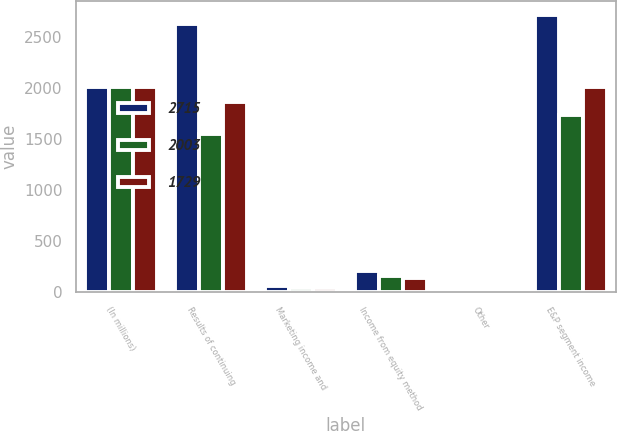<chart> <loc_0><loc_0><loc_500><loc_500><stacked_bar_chart><ecel><fcel>(In millions)<fcel>Results of continuing<fcel>Marketing income and<fcel>Income from equity method<fcel>Other<fcel>E&P segment income<nl><fcel>2715<fcel>2008<fcel>2625<fcel>58<fcel>201<fcel>6<fcel>2715<nl><fcel>2003<fcel>2007<fcel>1545<fcel>36<fcel>154<fcel>6<fcel>1729<nl><fcel>1729<fcel>2006<fcel>1858<fcel>40<fcel>135<fcel>1<fcel>2003<nl></chart> 